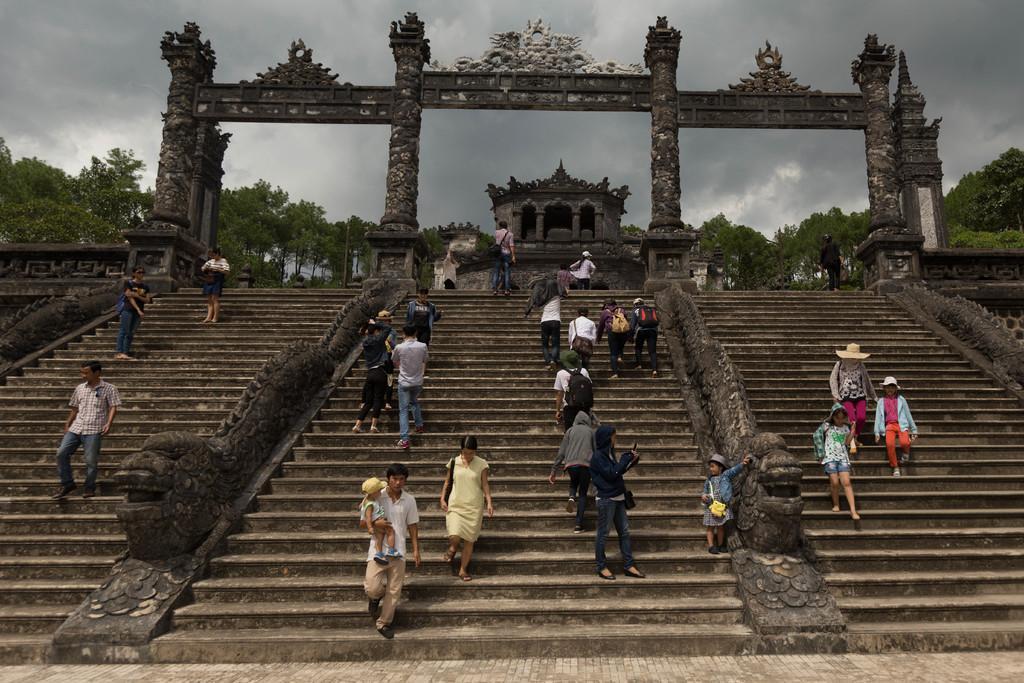Describe this image in one or two sentences. In this image we can see persons climbing staircase, sculptures, building, entrance arches, trees and sky with clouds. 